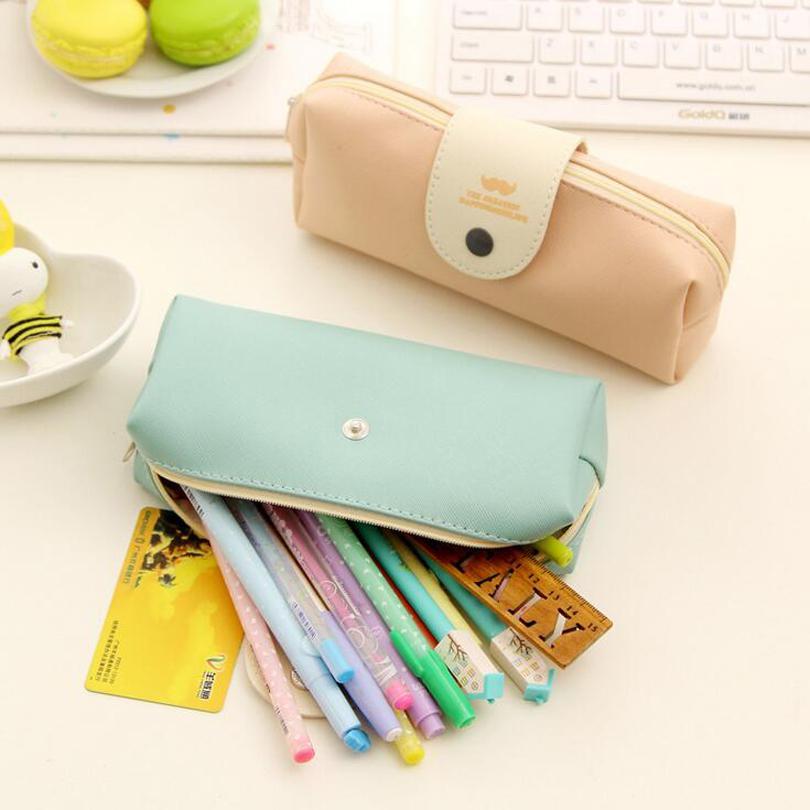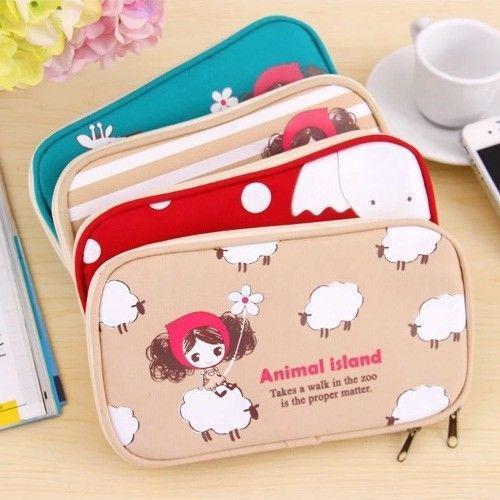The first image is the image on the left, the second image is the image on the right. For the images shown, is this caption "The right image depicts at least three pencil cases." true? Answer yes or no. Yes. 